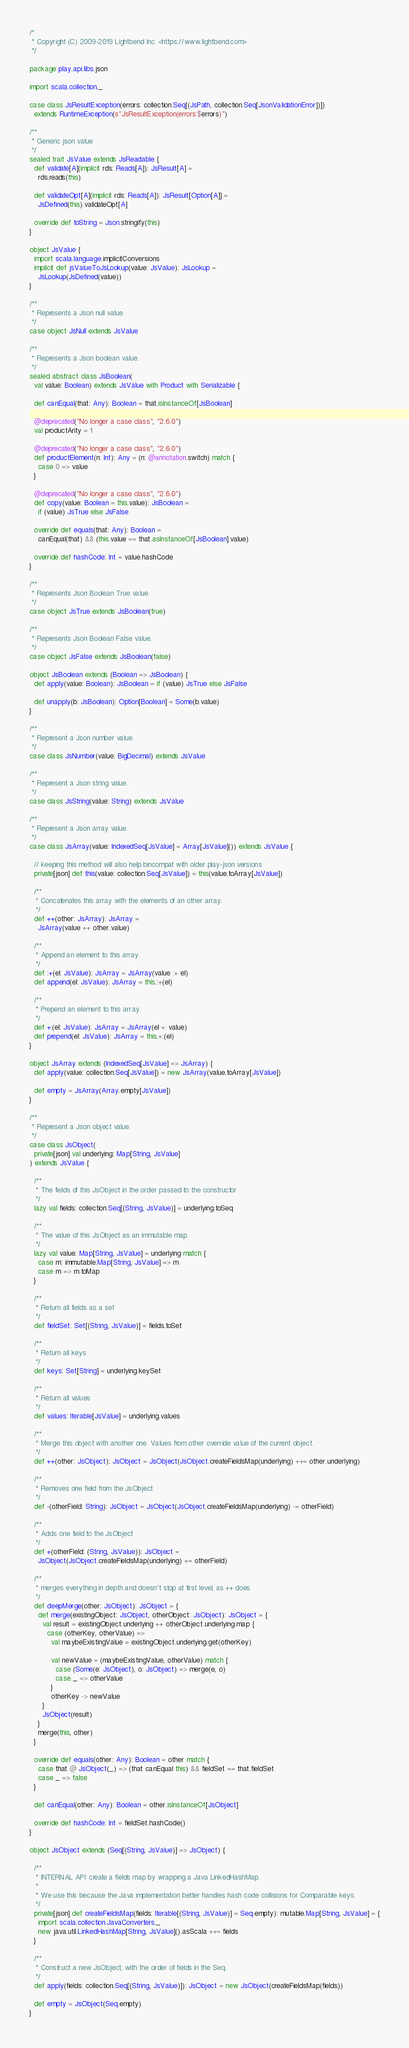<code> <loc_0><loc_0><loc_500><loc_500><_Scala_>/*
 * Copyright (C) 2009-2019 Lightbend Inc. <https://www.lightbend.com>
 */

package play.api.libs.json

import scala.collection._

case class JsResultException(errors: collection.Seq[(JsPath, collection.Seq[JsonValidationError])])
  extends RuntimeException(s"JsResultException(errors:$errors)")

/**
 * Generic json value
 */
sealed trait JsValue extends JsReadable {
  def validate[A](implicit rds: Reads[A]): JsResult[A] =
    rds.reads(this)

  def validateOpt[A](implicit rds: Reads[A]): JsResult[Option[A]] =
    JsDefined(this).validateOpt[A]

  override def toString = Json.stringify(this)
}

object JsValue {
  import scala.language.implicitConversions
  implicit def jsValueToJsLookup(value: JsValue): JsLookup =
    JsLookup(JsDefined(value))
}

/**
 * Represents a Json null value.
 */
case object JsNull extends JsValue

/**
 * Represents a Json boolean value.
 */
sealed abstract class JsBoolean(
  val value: Boolean) extends JsValue with Product with Serializable {

  def canEqual(that: Any): Boolean = that.isInstanceOf[JsBoolean]

  @deprecated("No longer a case class", "2.6.0")
  val productArity = 1

  @deprecated("No longer a case class", "2.6.0")
  def productElement(n: Int): Any = (n: @annotation.switch) match {
    case 0 => value
  }

  @deprecated("No longer a case class", "2.6.0")
  def copy(value: Boolean = this.value): JsBoolean =
    if (value) JsTrue else JsFalse

  override def equals(that: Any): Boolean =
    canEqual(that) && (this.value == that.asInstanceOf[JsBoolean].value)

  override def hashCode: Int = value.hashCode
}

/**
 * Represents Json Boolean True value.
 */
case object JsTrue extends JsBoolean(true)

/**
 * Represents Json Boolean False value.
 */
case object JsFalse extends JsBoolean(false)

object JsBoolean extends (Boolean => JsBoolean) {
  def apply(value: Boolean): JsBoolean = if (value) JsTrue else JsFalse

  def unapply(b: JsBoolean): Option[Boolean] = Some(b.value)
}

/**
 * Represent a Json number value.
 */
case class JsNumber(value: BigDecimal) extends JsValue

/**
 * Represent a Json string value.
 */
case class JsString(value: String) extends JsValue

/**
 * Represent a Json array value.
 */
case class JsArray(value: IndexedSeq[JsValue] = Array[JsValue]()) extends JsValue {

  // keeping this method will also help bincompat with older play-json versions
  private[json] def this(value: collection.Seq[JsValue]) = this(value.toArray[JsValue])

  /**
   * Concatenates this array with the elements of an other array.
   */
  def ++(other: JsArray): JsArray =
    JsArray(value ++ other.value)

  /**
   * Append an element to this array.
   */
  def :+(el: JsValue): JsArray = JsArray(value :+ el)
  def append(el: JsValue): JsArray = this.:+(el)

  /**
   * Prepend an element to this array.
   */
  def +:(el: JsValue): JsArray = JsArray(el +: value)
  def prepend(el: JsValue): JsArray = this.+:(el)
}

object JsArray extends (IndexedSeq[JsValue] => JsArray) {
  def apply(value: collection.Seq[JsValue]) = new JsArray(value.toArray[JsValue])

  def empty = JsArray(Array.empty[JsValue])
}

/**
 * Represent a Json object value.
 */
case class JsObject(
  private[json] val underlying: Map[String, JsValue]
) extends JsValue {

  /**
   * The fields of this JsObject in the order passed to the constructor
   */
  lazy val fields: collection.Seq[(String, JsValue)] = underlying.toSeq

  /**
   * The value of this JsObject as an immutable map.
   */
  lazy val value: Map[String, JsValue] = underlying match {
    case m: immutable.Map[String, JsValue] => m
    case m => m.toMap
  }

  /**
   * Return all fields as a set
   */
  def fieldSet: Set[(String, JsValue)] = fields.toSet

  /**
   * Return all keys
   */
  def keys: Set[String] = underlying.keySet

  /**
   * Return all values
   */
  def values: Iterable[JsValue] = underlying.values

  /**
   * Merge this object with another one. Values from other override value of the current object.
   */
  def ++(other: JsObject): JsObject = JsObject(JsObject.createFieldsMap(underlying) ++= other.underlying)

  /**
   * Removes one field from the JsObject
   */
  def -(otherField: String): JsObject = JsObject(JsObject.createFieldsMap(underlying) -= otherField)

  /**
   * Adds one field to the JsObject
   */
  def +(otherField: (String, JsValue)): JsObject =
    JsObject(JsObject.createFieldsMap(underlying) += otherField)

  /**
   * merges everything in depth and doesn't stop at first level, as ++ does
   */
  def deepMerge(other: JsObject): JsObject = {
    def merge(existingObject: JsObject, otherObject: JsObject): JsObject = {
      val result = existingObject.underlying ++ otherObject.underlying.map {
        case (otherKey, otherValue) =>
          val maybeExistingValue = existingObject.underlying.get(otherKey)

          val newValue = (maybeExistingValue, otherValue) match {
            case (Some(e: JsObject), o: JsObject) => merge(e, o)
            case _ => otherValue
          }
          otherKey -> newValue
      }
      JsObject(result)
    }
    merge(this, other)
  }

  override def equals(other: Any): Boolean = other match {
    case that @ JsObject(_) => (that canEqual this) && fieldSet == that.fieldSet
    case _ => false
  }

  def canEqual(other: Any): Boolean = other.isInstanceOf[JsObject]

  override def hashCode: Int = fieldSet.hashCode()
}

object JsObject extends (Seq[(String, JsValue)] => JsObject) {

  /**
   * INTERNAL API: create a fields map by wrapping a Java LinkedHashMap.
   *
   * We use this because the Java implementation better handles hash code collisions for Comparable keys.
   */
  private[json] def createFieldsMap(fields: Iterable[(String, JsValue)] = Seq.empty): mutable.Map[String, JsValue] = {
    import scala.collection.JavaConverters._
    new java.util.LinkedHashMap[String, JsValue]().asScala ++= fields
  }

  /**
   * Construct a new JsObject, with the order of fields in the Seq.
   */
  def apply(fields: collection.Seq[(String, JsValue)]): JsObject = new JsObject(createFieldsMap(fields))

  def empty = JsObject(Seq.empty)
}
</code> 